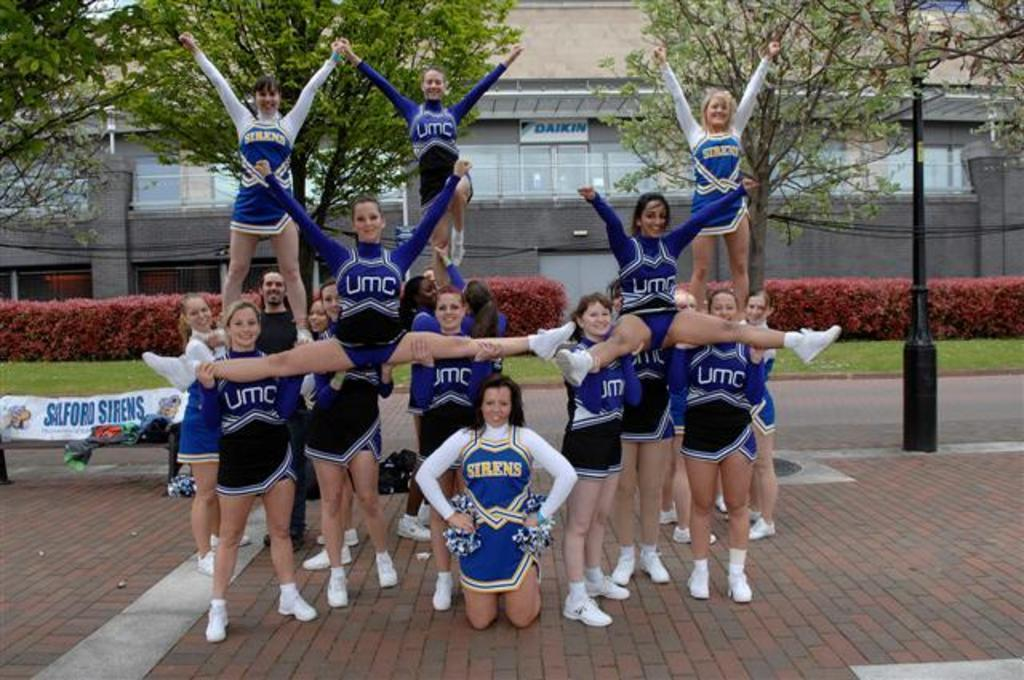Provide a one-sentence caption for the provided image. Sirens and UMC cheerleaders are in a pyramid pose. 